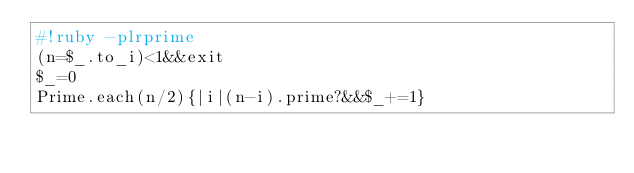Convert code to text. <code><loc_0><loc_0><loc_500><loc_500><_Ruby_>#!ruby -plrprime
(n=$_.to_i)<1&&exit
$_=0
Prime.each(n/2){|i|(n-i).prime?&&$_+=1}</code> 